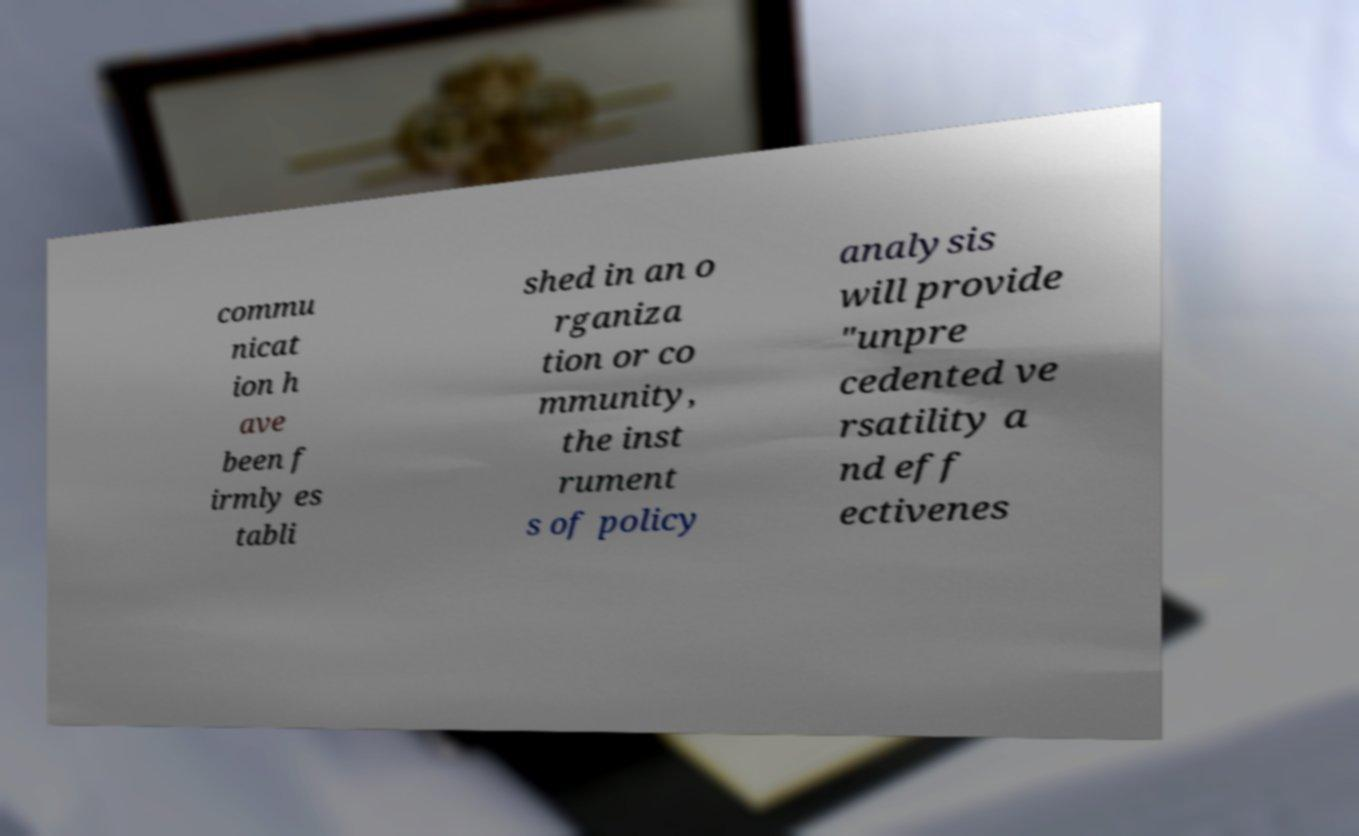Please identify and transcribe the text found in this image. commu nicat ion h ave been f irmly es tabli shed in an o rganiza tion or co mmunity, the inst rument s of policy analysis will provide "unpre cedented ve rsatility a nd eff ectivenes 